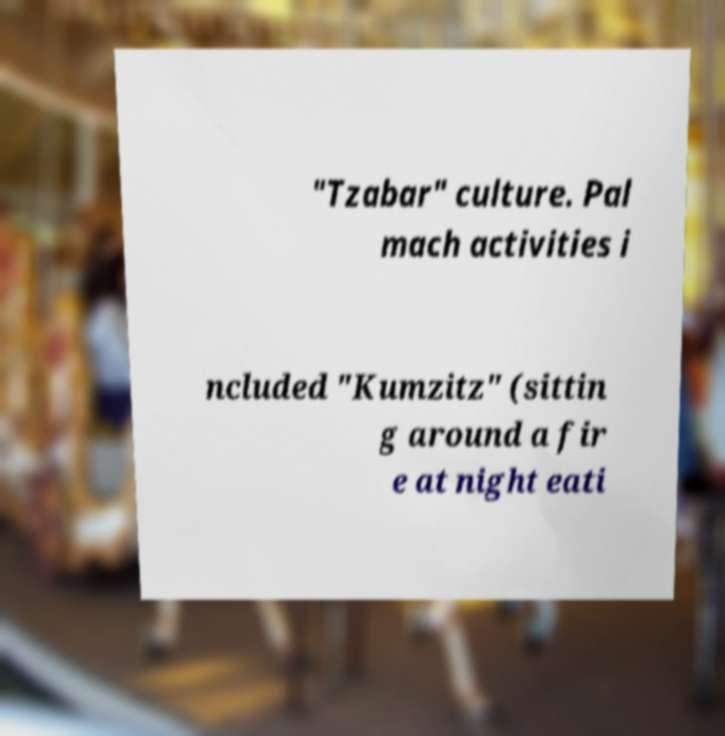Could you assist in decoding the text presented in this image and type it out clearly? "Tzabar" culture. Pal mach activities i ncluded "Kumzitz" (sittin g around a fir e at night eati 